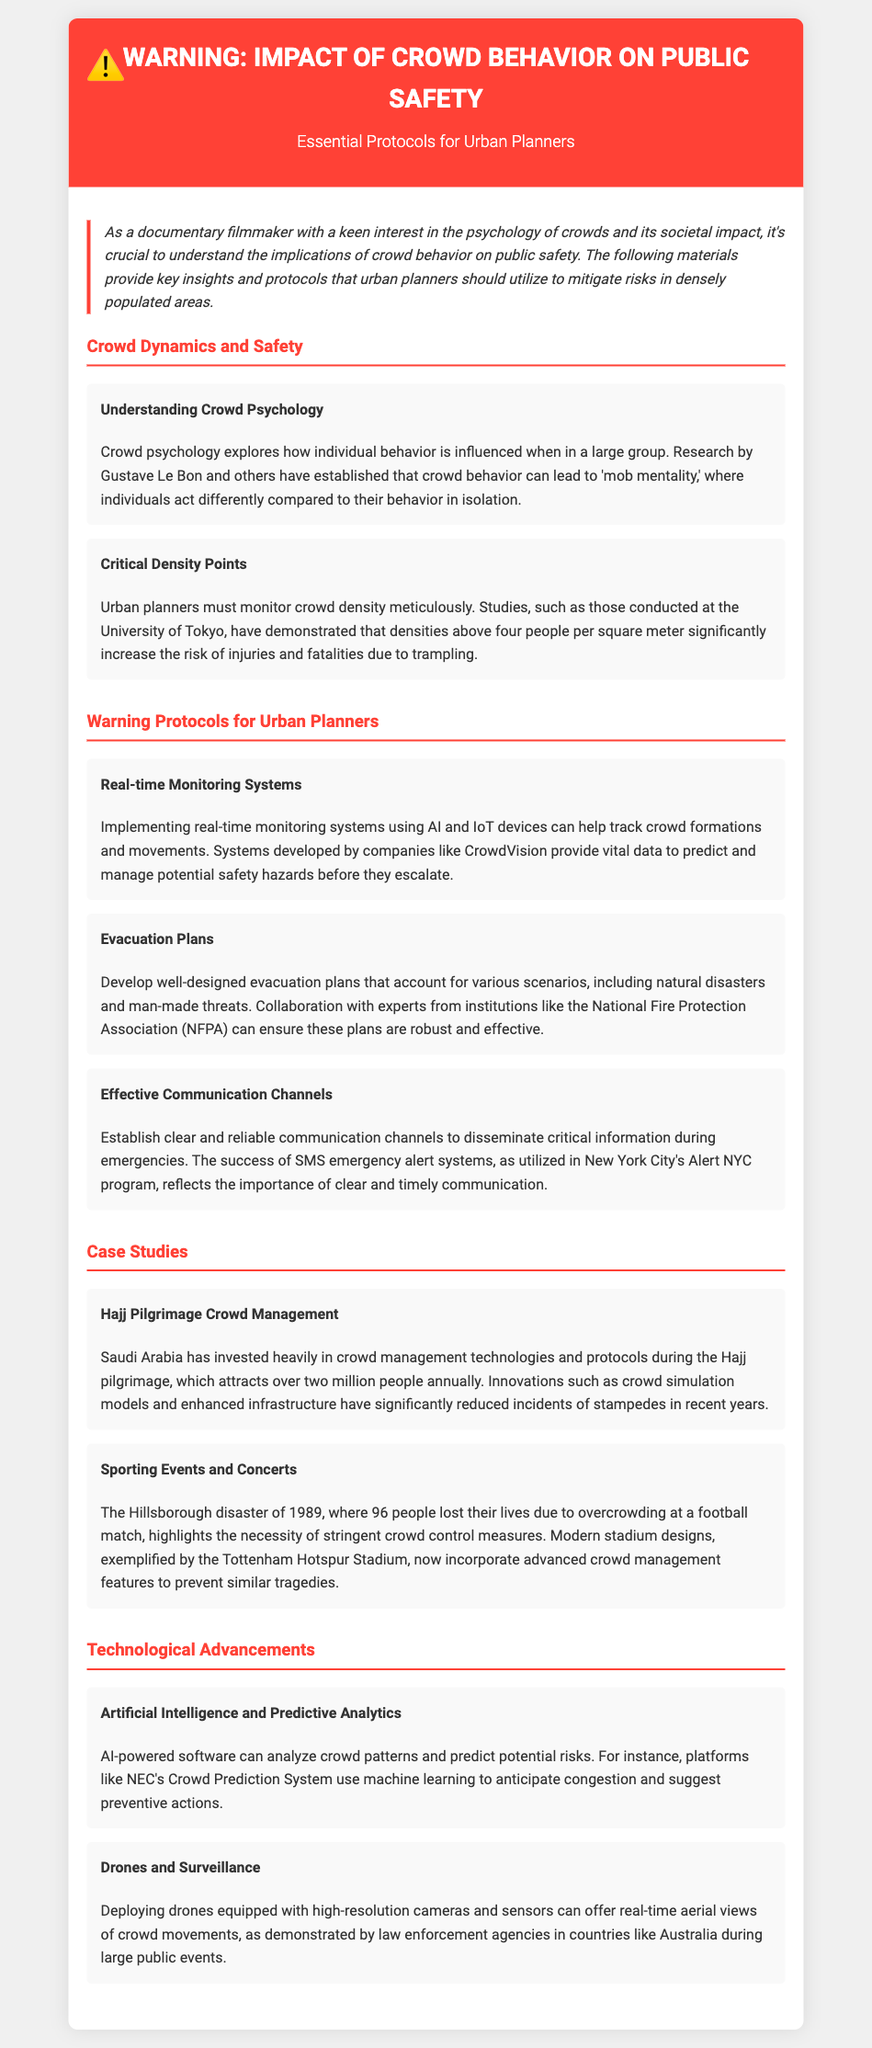What is the title of this document? The title of the document is given in the header section, which prominently displays the title.
Answer: Warning: Impact of Crowd Behavior on Public Safety What is a key factor that increases the risk of injuries in crowds? The document mentions crowd density as a critical factor, specifically highlighting the threshold above which risks increase.
Answer: Four people per square meter Which technology is suggested for real-time monitoring of crowds? The document discusses implementing AI and IoT devices for tracking crowd formations and movements.
Answer: AI and IoT devices Who can help ensure robust evacuation plans? The document recommends collaboration with a specific organization for effective planning.
Answer: National Fire Protection Association (NFPA) What is one case study mentioned related to crowd management? The document includes case studies that illustrate effective crowd management at large events.
Answer: Hajj Pilgrimage What advanced technology does NEC use for crowd risk prediction? The document explains that a specific type of software is utilized for predicting crowd patterns.
Answer: Crowd Prediction System What role do drones play in crowd monitoring? The document describes how drones contribute to crowd management during public events.
Answer: Real-time aerial views What tragic event is referenced to emphasize the need for better crowd control? The document cites a significant historical disaster that underscores the importance of crowd management measures.
Answer: Hillsborough disaster 